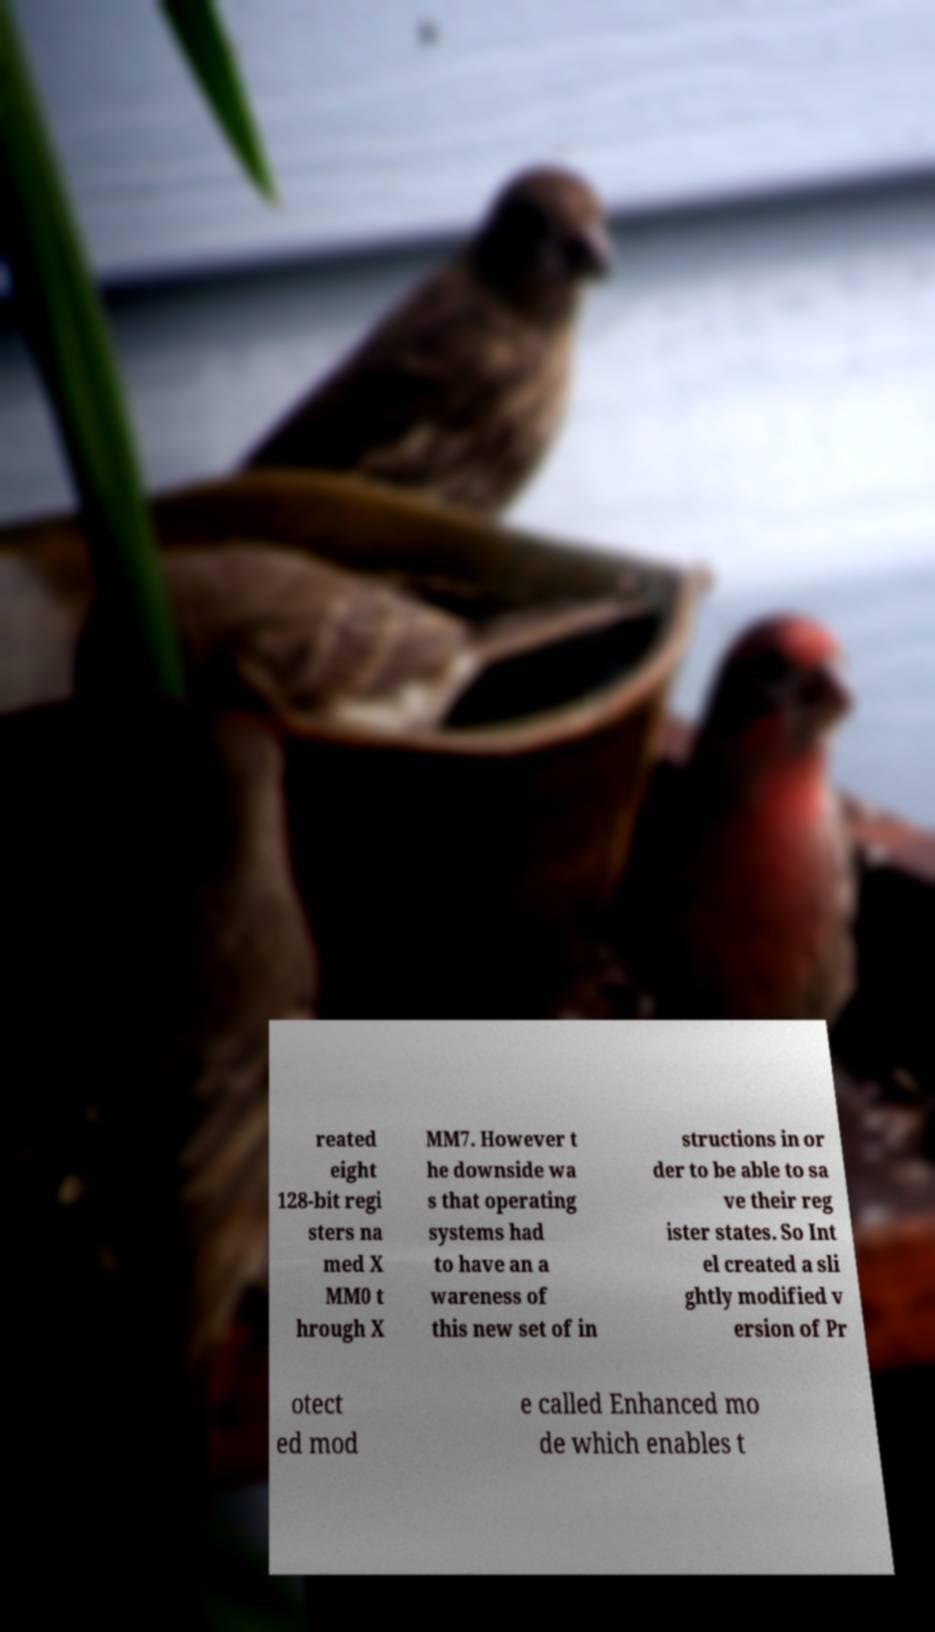There's text embedded in this image that I need extracted. Can you transcribe it verbatim? reated eight 128-bit regi sters na med X MM0 t hrough X MM7. However t he downside wa s that operating systems had to have an a wareness of this new set of in structions in or der to be able to sa ve their reg ister states. So Int el created a sli ghtly modified v ersion of Pr otect ed mod e called Enhanced mo de which enables t 